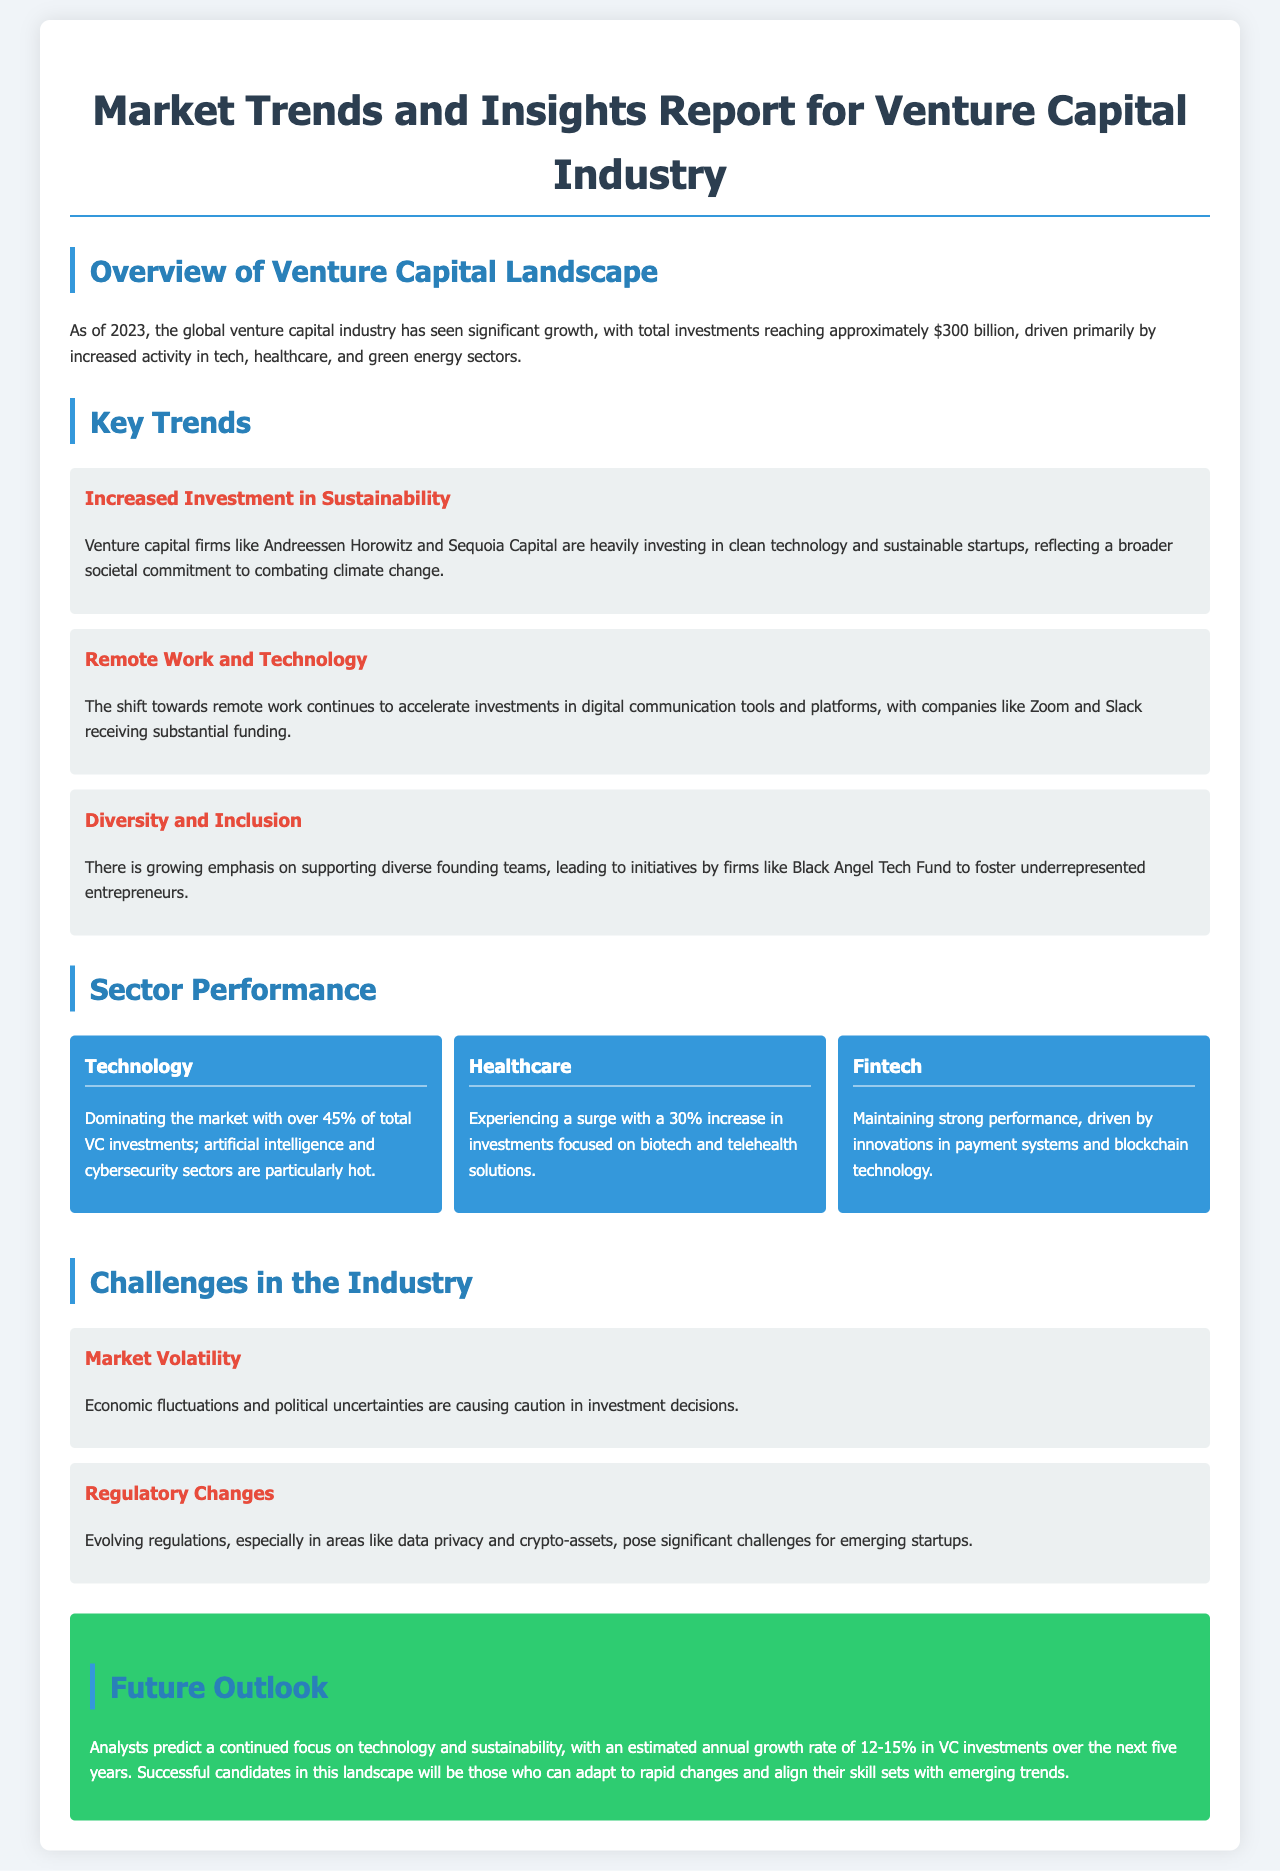What is the total investment in the global venture capital industry as of 2023? The total investment reached approximately $300 billion, as stated in the Overview of the Venture Capital Landscape.
Answer: $300 billion Which sector received over 45% of total VC investments? The Technology sector dominates, as mentioned in the Sector Performance section.
Answer: Technology What trend reflects a commitment to combating climate change? The increased investment in sustainability is highlighted in the Key Trends section.
Answer: Increased Investment in Sustainability What is the estimated annual growth rate of VC investments over the next five years? Analysts predict an estimated annual growth rate of 12-15%, according to the Future Outlook section.
Answer: 12-15% Which venture capital firm supports underrepresented entrepreneurs? The Black Angel Tech Fund is mentioned as supporting diverse founding teams in the Key Trends section.
Answer: Black Angel Tech Fund What challenge is related to economic fluctuations? Market Volatility is identified as a challenge in the Challenges in the Industry section.
Answer: Market Volatility Which sectors are highlighted as particularly hot within the Technology sector? Artificial intelligence and cybersecurity sectors are specifically mentioned as hot in the Sector Performance section.
Answer: Artificial intelligence and cybersecurity What type of companies are experiencing a surge in investments in the Healthcare sector? Biotech and telehealth solutions are identified as experiencing a surge in investments.
Answer: Biotech and telehealth solutions 